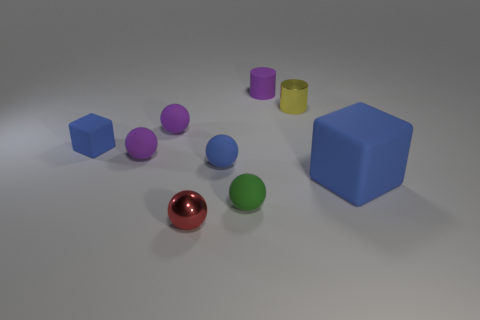Subtract all green spheres. How many spheres are left? 4 Subtract all cyan balls. Subtract all purple blocks. How many balls are left? 5 Add 1 cyan metallic spheres. How many objects exist? 10 Subtract all spheres. How many objects are left? 4 Subtract 0 brown balls. How many objects are left? 9 Subtract all small purple matte cylinders. Subtract all blue objects. How many objects are left? 5 Add 5 blue rubber objects. How many blue rubber objects are left? 8 Add 1 big blue blocks. How many big blue blocks exist? 2 